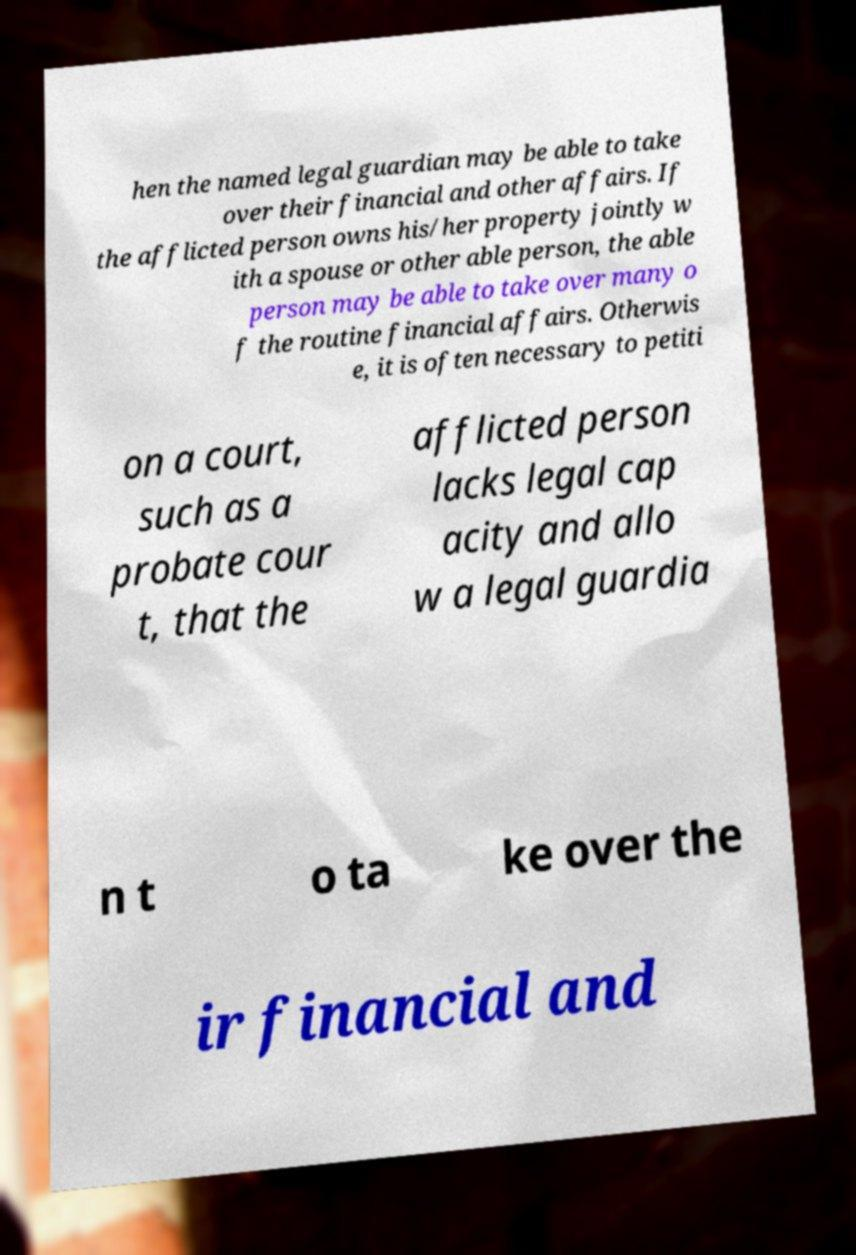Can you read and provide the text displayed in the image?This photo seems to have some interesting text. Can you extract and type it out for me? hen the named legal guardian may be able to take over their financial and other affairs. If the afflicted person owns his/her property jointly w ith a spouse or other able person, the able person may be able to take over many o f the routine financial affairs. Otherwis e, it is often necessary to petiti on a court, such as a probate cour t, that the afflicted person lacks legal cap acity and allo w a legal guardia n t o ta ke over the ir financial and 